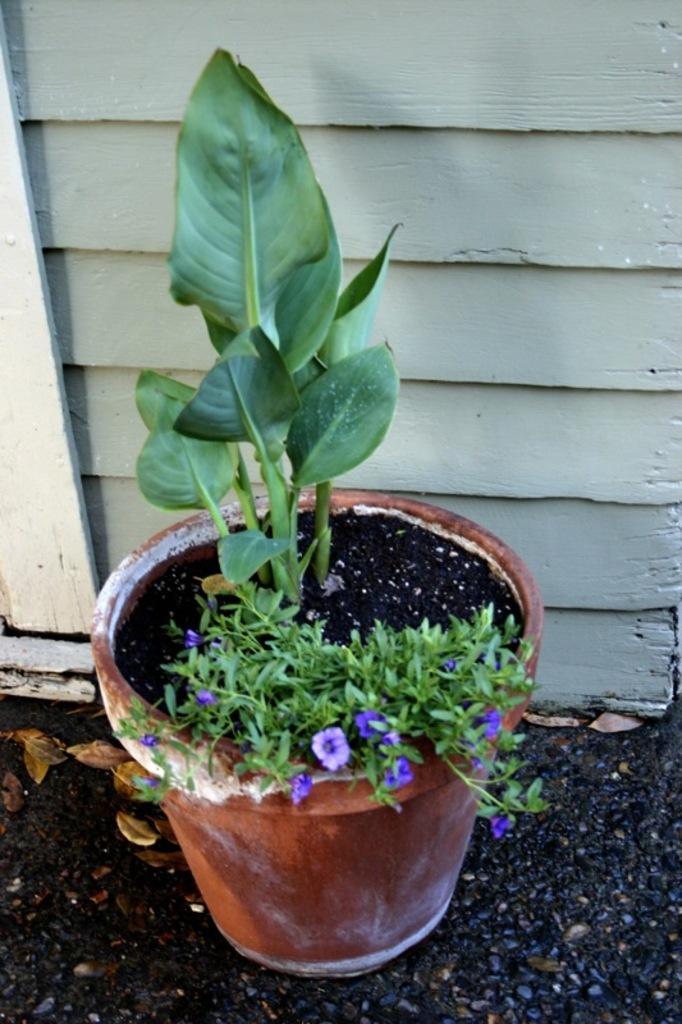Please provide a concise description of this image. The image consists of a pot in which there is a plant. At the bottom, there is sand. In the background, there is a wall made up wood. 